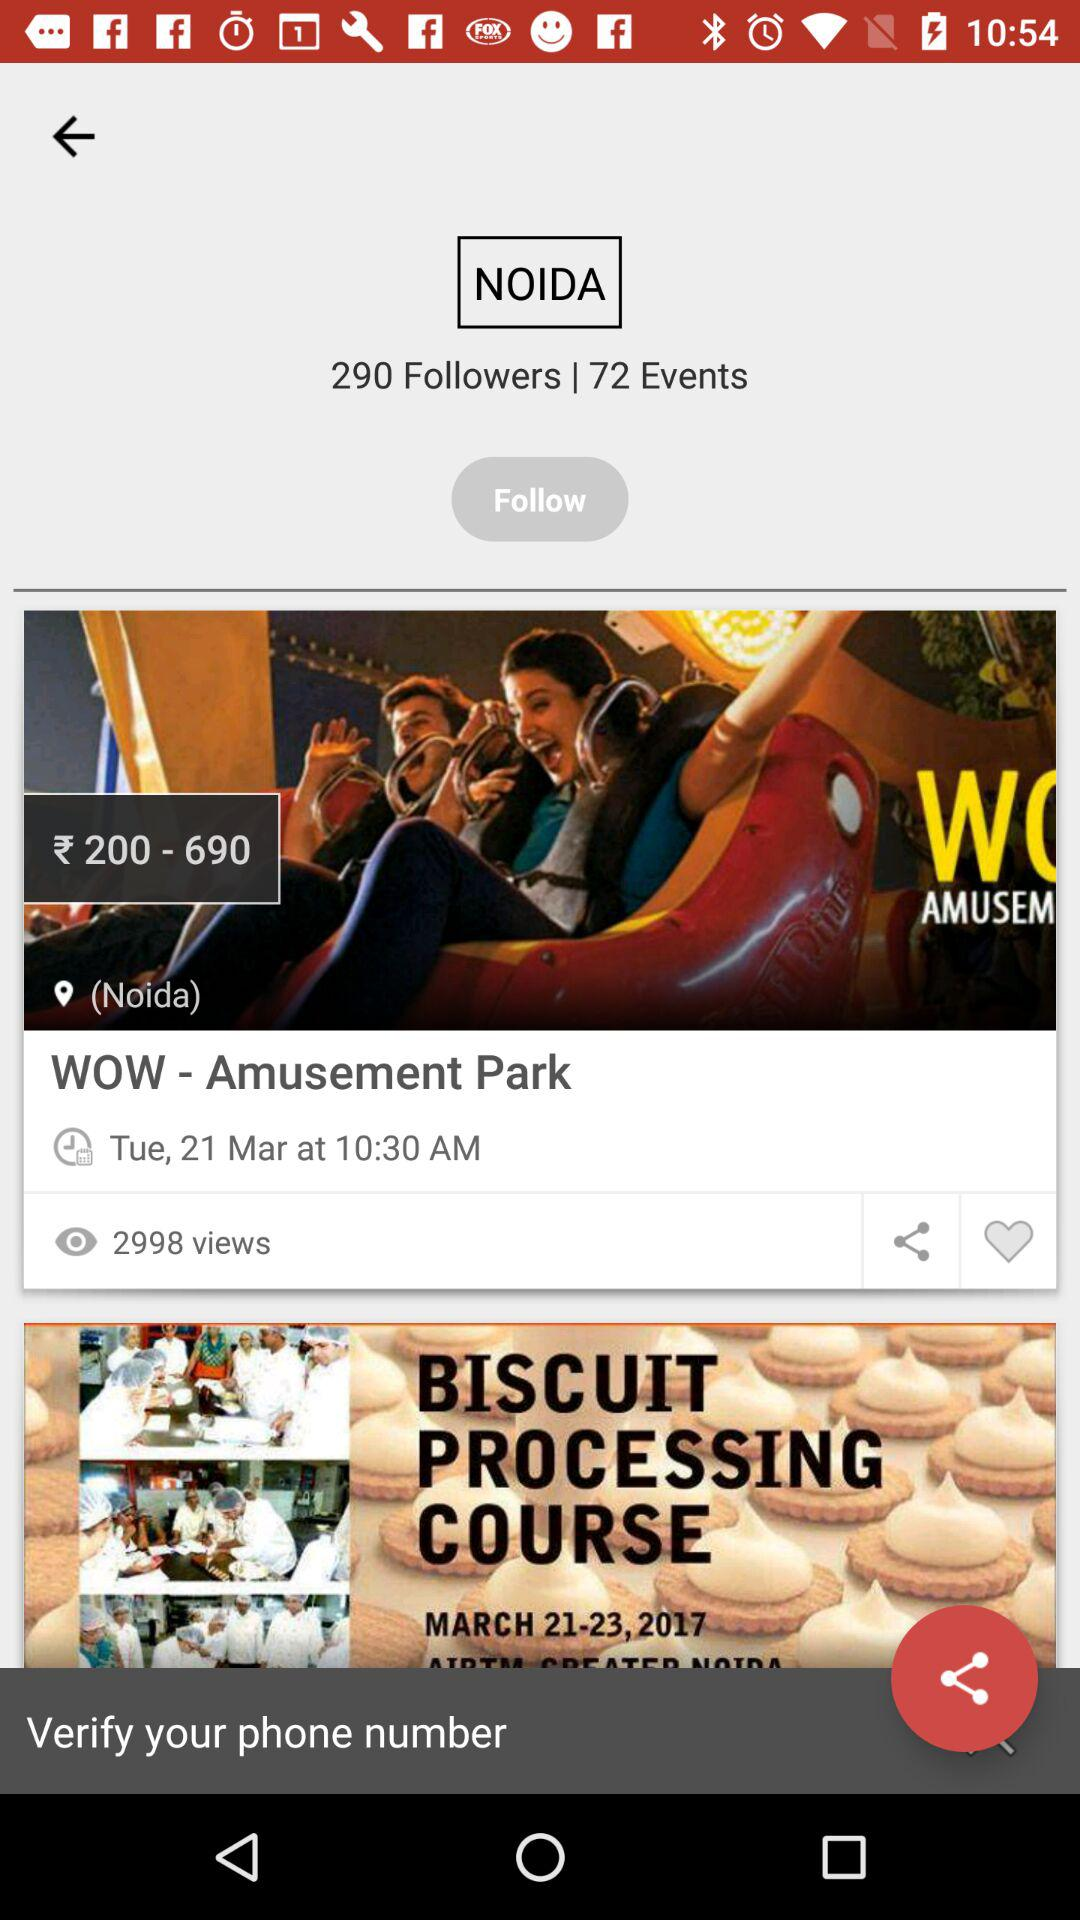How many followers are there in this account?
Answer the question using a single word or phrase. 290 